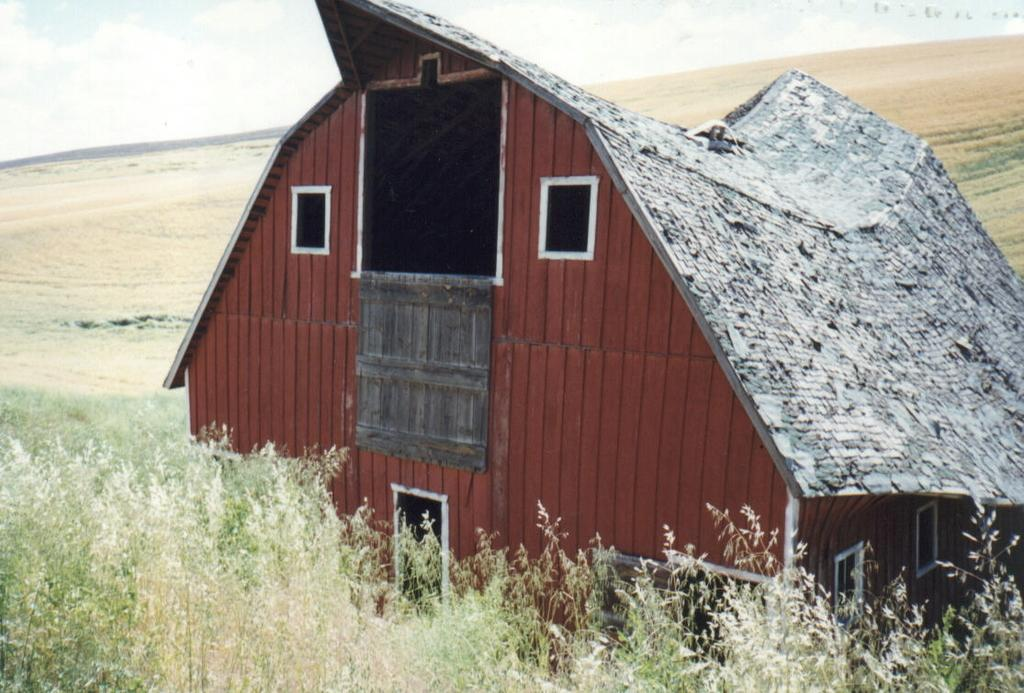What type of structure is present in the image? There is a building in the image. What type of vegetation can be seen at the back of the image? There is grass visible at the back of the image. What is visible at the top of the image? The sky is visible at the top of the image. What type of vegetation is present at the bottom of the image? There are plants at the bottom of the image. What type of pancake is being served at the building in the image? There is no pancake present in the image, and no indication of food being served. 